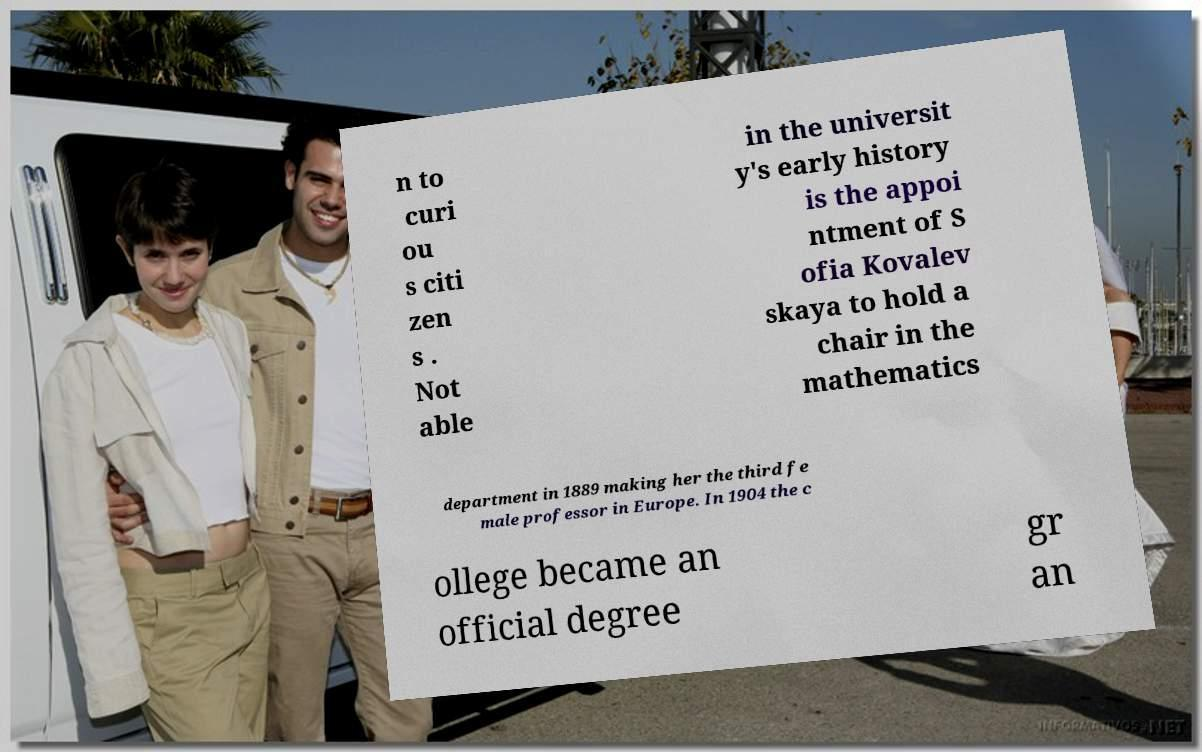Please identify and transcribe the text found in this image. n to curi ou s citi zen s . Not able in the universit y's early history is the appoi ntment of S ofia Kovalev skaya to hold a chair in the mathematics department in 1889 making her the third fe male professor in Europe. In 1904 the c ollege became an official degree gr an 